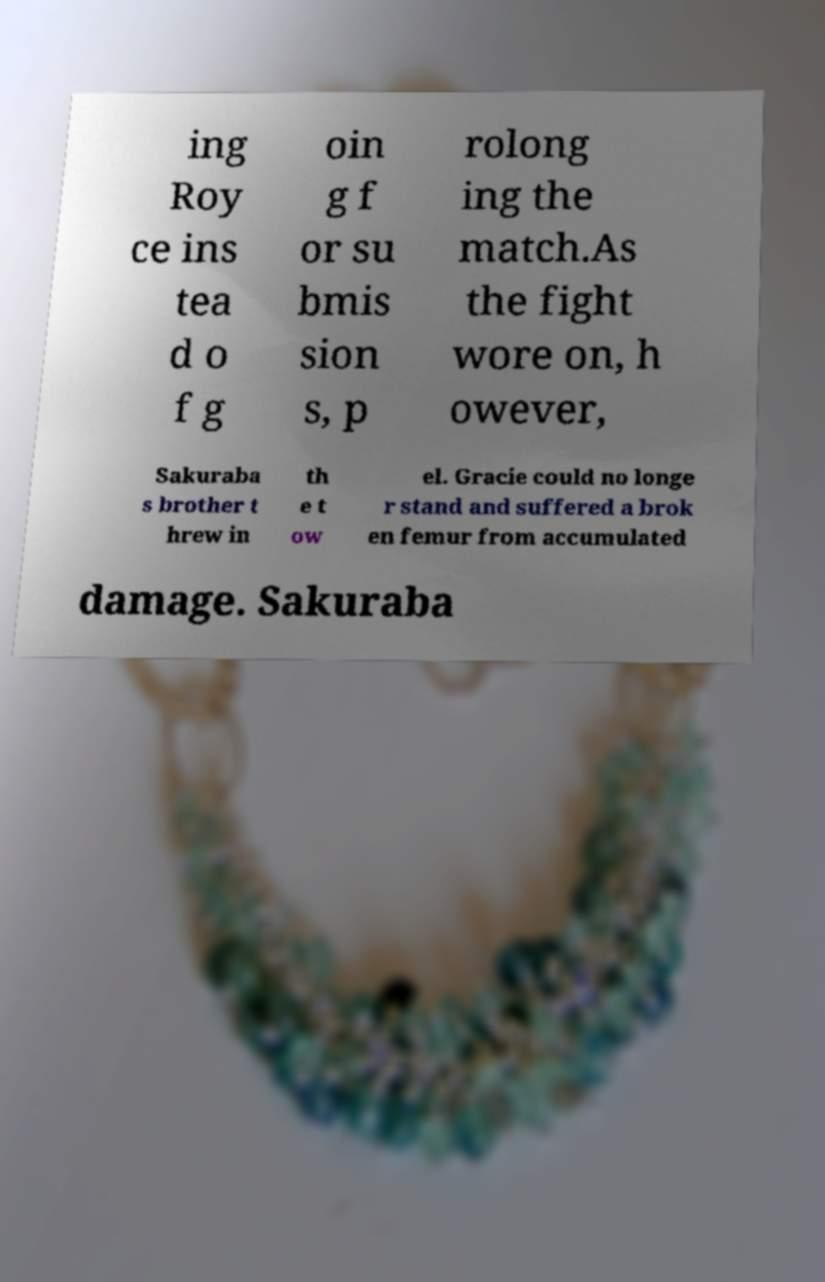Could you assist in decoding the text presented in this image and type it out clearly? ing Roy ce ins tea d o f g oin g f or su bmis sion s, p rolong ing the match.As the fight wore on, h owever, Sakuraba s brother t hrew in th e t ow el. Gracie could no longe r stand and suffered a brok en femur from accumulated damage. Sakuraba 